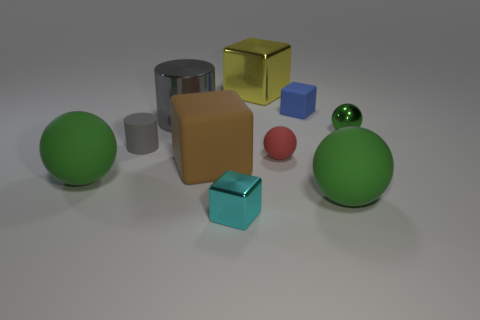Which objects in the image appear to be capable of reflecting light sharply? The objects capable of reflecting light sharply are the tiny shiny silver cylinder, the gold cube, and the small turquoise cube due to their smooth and polished surfaces.  How do the textures of objects in the scene vary? The textures in the scene vary significantly. The spheres and the large cubes have matte finishes that diffuse light, giving them a soft appearance, while the tiny silver cylinder, gold cube, and small turquoise cube have glossy finishes that reflect light, resulting in a bright and sharp appearance. 